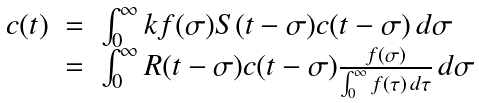<formula> <loc_0><loc_0><loc_500><loc_500>\begin{array} { l c l } c ( t ) & = & \int _ { 0 } ^ { \infty } k f ( \sigma ) S ( t - \sigma ) c ( t - \sigma ) \, d \sigma \\ & = & \int _ { 0 } ^ { \infty } R ( t - \sigma ) c ( t - \sigma ) \frac { f ( \sigma ) } { \int _ { 0 } ^ { \infty } f ( \tau ) \, d \tau } \, d \sigma \end{array}</formula> 